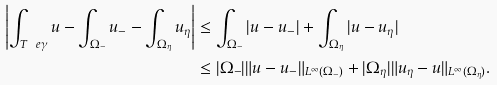<formula> <loc_0><loc_0><loc_500><loc_500>\left | \int _ { T _ { \ } e \gamma } u - \int _ { \Omega _ { - } } u _ { - } - \int _ { \Omega _ { \eta } } u _ { \eta } \right | & \leq \int _ { \Omega _ { - } } | u - u _ { - } | + \int _ { \Omega _ { \eta } } | u - u _ { \eta } | \\ & \leq | \Omega _ { - } | \| u - u _ { - } \| _ { L ^ { \infty } ( \Omega _ { - } ) } + | \Omega _ { \eta } | \| u _ { \eta } - u \| _ { L ^ { \infty } ( \Omega _ { \eta } ) } .</formula> 